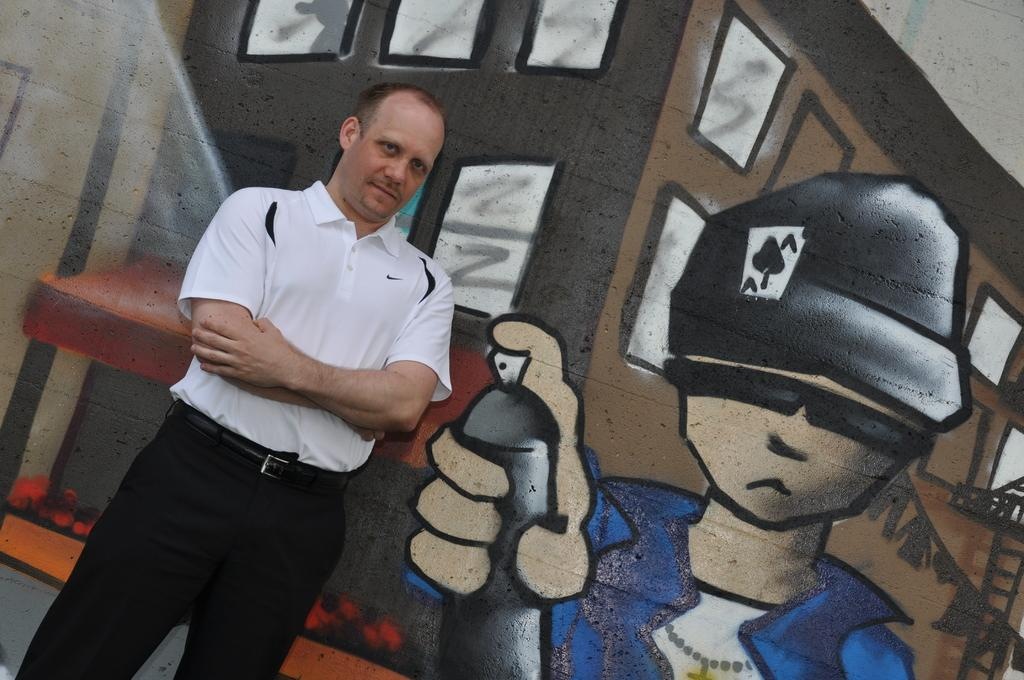Who or what is the main subject in the image? There is a person in the image. What is the person wearing? The person is wearing a white T-shirt. Where is the person located in the image? The person is standing near a wall. What can be seen on the wall in the background of the image? There is graffiti on a wall in the background of the image. What type of office can be seen in the image? There is no office visible in the image. 